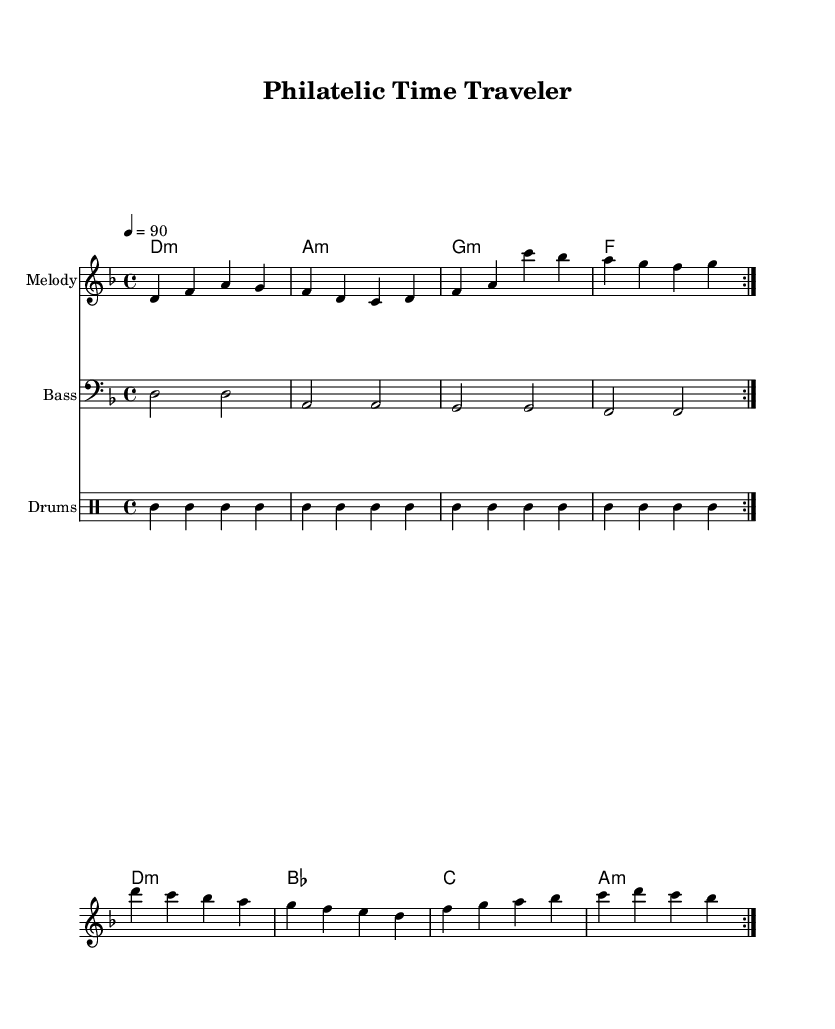What is the key signature of this music? The key signature is indicated at the beginning of the score, showing two flats, which corresponds to D minor.
Answer: D minor What is the time signature of this music? The time signature is found right after the key signature, indicated as 4/4, meaning there are four beats in a measure.
Answer: 4/4 What is the tempo marking of this music? The tempo marking appears above the staff and shows "4 = 90," which indicates a tempo of 90 beats per minute in quarter note values.
Answer: 90 How many volta sections are repeated in the melody? The melody is marked with "repeat volta 2," meaning that the melody section is repeated two times.
Answer: 2 What type of music genre is this composition? The title "Philatelic Time Traveler" suggests a thematic exploration which aligns with a hip hop genre, particularly focusing on storytelling and lyrical narratives.
Answer: Hip Hop What instruments are featured in this score? The score includes a melody staff (treble), a bass staff (bass), and a drum staff for percussion, indicating a broader band arrangement typical in hip hop music.
Answer: Melody, Bass, Drums How many bars are in the repeated melody section? The melody, which is repeated two times, consists of eight bars in total (four bars in each iteration). Each vuelta contains four measures.
Answer: 8 